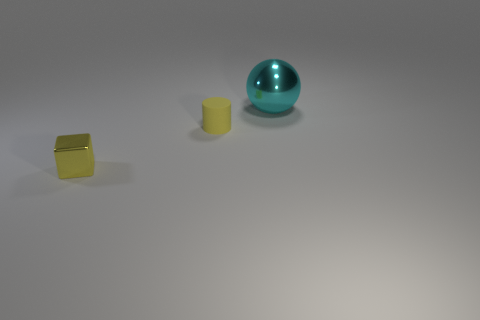How many things are the same size as the cyan sphere?
Ensure brevity in your answer.  0. There is a cyan ball behind the shiny thing that is in front of the big metallic object; what is it made of?
Give a very brief answer. Metal. What is the shape of the metallic thing in front of the metal thing that is behind the small object that is behind the tiny metal cube?
Your answer should be very brief. Cube. Is the shape of the yellow thing that is behind the metallic cube the same as the thing behind the small yellow cylinder?
Your answer should be very brief. No. How many other things are there of the same material as the cube?
Your answer should be compact. 1. There is a cyan object that is the same material as the block; what shape is it?
Keep it short and to the point. Sphere. Do the cyan ball and the metallic block have the same size?
Your answer should be very brief. No. There is a yellow object that is behind the tiny yellow thing left of the small yellow matte object; what is its size?
Give a very brief answer. Small. There is a thing that is the same color as the block; what is its shape?
Ensure brevity in your answer.  Cylinder. What number of spheres are either yellow metal things or purple shiny objects?
Ensure brevity in your answer.  0. 